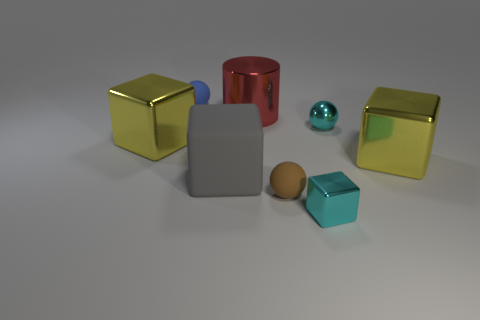There is a brown rubber object that is the same size as the blue rubber sphere; what shape is it?
Provide a short and direct response. Sphere. How many objects are either tiny cyan matte cylinders or small brown rubber things?
Provide a short and direct response. 1. Is there a big purple cylinder?
Your answer should be very brief. No. Are there fewer tiny red rubber things than large red shiny cylinders?
Provide a succinct answer. Yes. Are there any gray things of the same size as the metal cylinder?
Provide a short and direct response. Yes. Is the shape of the large gray rubber object the same as the large shiny thing that is left of the big gray block?
Make the answer very short. Yes. What number of cylinders are tiny yellow metal objects or small blue matte things?
Provide a short and direct response. 0. What is the color of the shiny sphere?
Provide a short and direct response. Cyan. Is the number of tiny matte objects greater than the number of cyan blocks?
Ensure brevity in your answer.  Yes. How many things are either large objects that are right of the large red shiny cylinder or cyan metallic objects?
Provide a short and direct response. 3. 